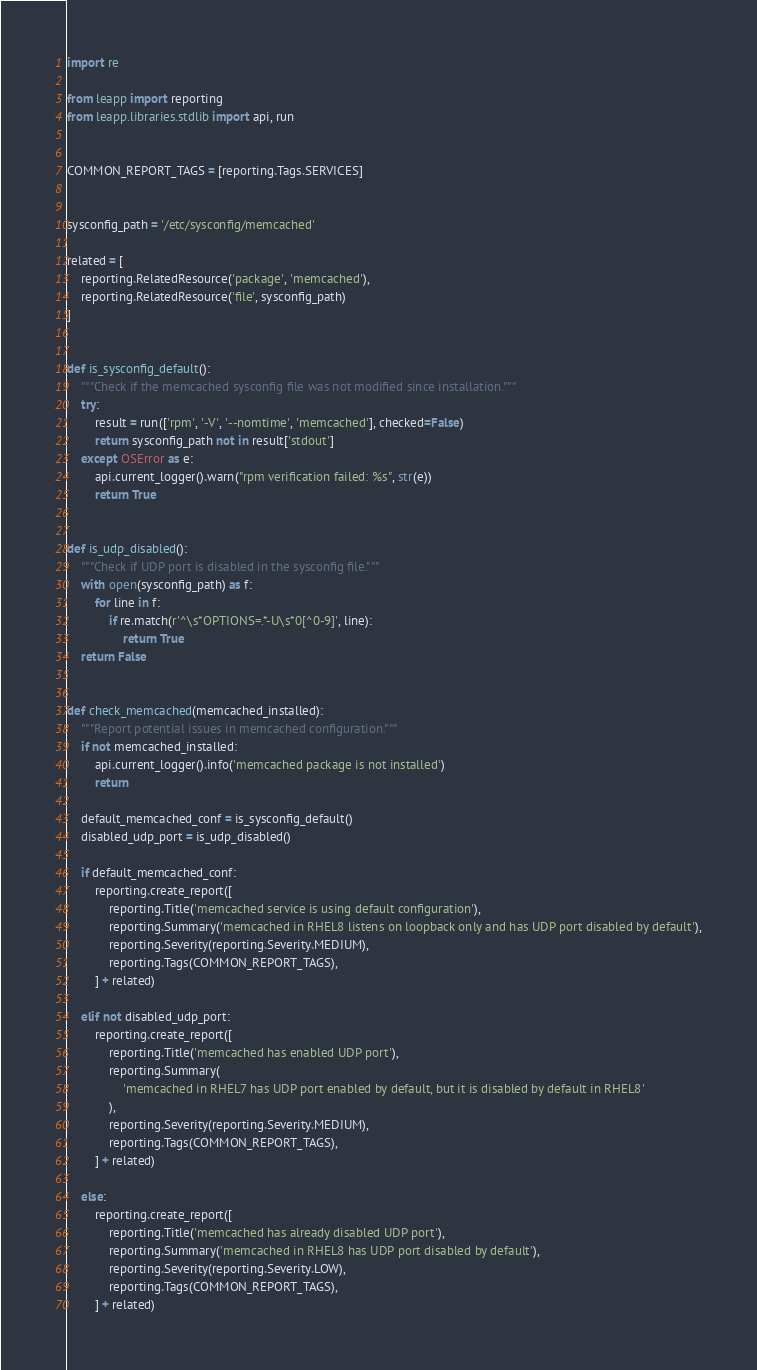Convert code to text. <code><loc_0><loc_0><loc_500><loc_500><_Python_>import re

from leapp import reporting
from leapp.libraries.stdlib import api, run


COMMON_REPORT_TAGS = [reporting.Tags.SERVICES]


sysconfig_path = '/etc/sysconfig/memcached'

related = [
    reporting.RelatedResource('package', 'memcached'),
    reporting.RelatedResource('file', sysconfig_path)
]


def is_sysconfig_default():
    """Check if the memcached sysconfig file was not modified since installation."""
    try:
        result = run(['rpm', '-V', '--nomtime', 'memcached'], checked=False)
        return sysconfig_path not in result['stdout']
    except OSError as e:
        api.current_logger().warn("rpm verification failed: %s", str(e))
        return True


def is_udp_disabled():
    """Check if UDP port is disabled in the sysconfig file."""
    with open(sysconfig_path) as f:
        for line in f:
            if re.match(r'^\s*OPTIONS=.*-U\s*0[^0-9]', line):
                return True
    return False


def check_memcached(memcached_installed):
    """Report potential issues in memcached configuration."""
    if not memcached_installed:
        api.current_logger().info('memcached package is not installed')
        return

    default_memcached_conf = is_sysconfig_default()
    disabled_udp_port = is_udp_disabled()

    if default_memcached_conf:
        reporting.create_report([
            reporting.Title('memcached service is using default configuration'),
            reporting.Summary('memcached in RHEL8 listens on loopback only and has UDP port disabled by default'),
            reporting.Severity(reporting.Severity.MEDIUM),
            reporting.Tags(COMMON_REPORT_TAGS),
        ] + related)

    elif not disabled_udp_port:
        reporting.create_report([
            reporting.Title('memcached has enabled UDP port'),
            reporting.Summary(
                'memcached in RHEL7 has UDP port enabled by default, but it is disabled by default in RHEL8'
            ),
            reporting.Severity(reporting.Severity.MEDIUM),
            reporting.Tags(COMMON_REPORT_TAGS),
        ] + related)

    else:
        reporting.create_report([
            reporting.Title('memcached has already disabled UDP port'),
            reporting.Summary('memcached in RHEL8 has UDP port disabled by default'),
            reporting.Severity(reporting.Severity.LOW),
            reporting.Tags(COMMON_REPORT_TAGS),
        ] + related)
</code> 